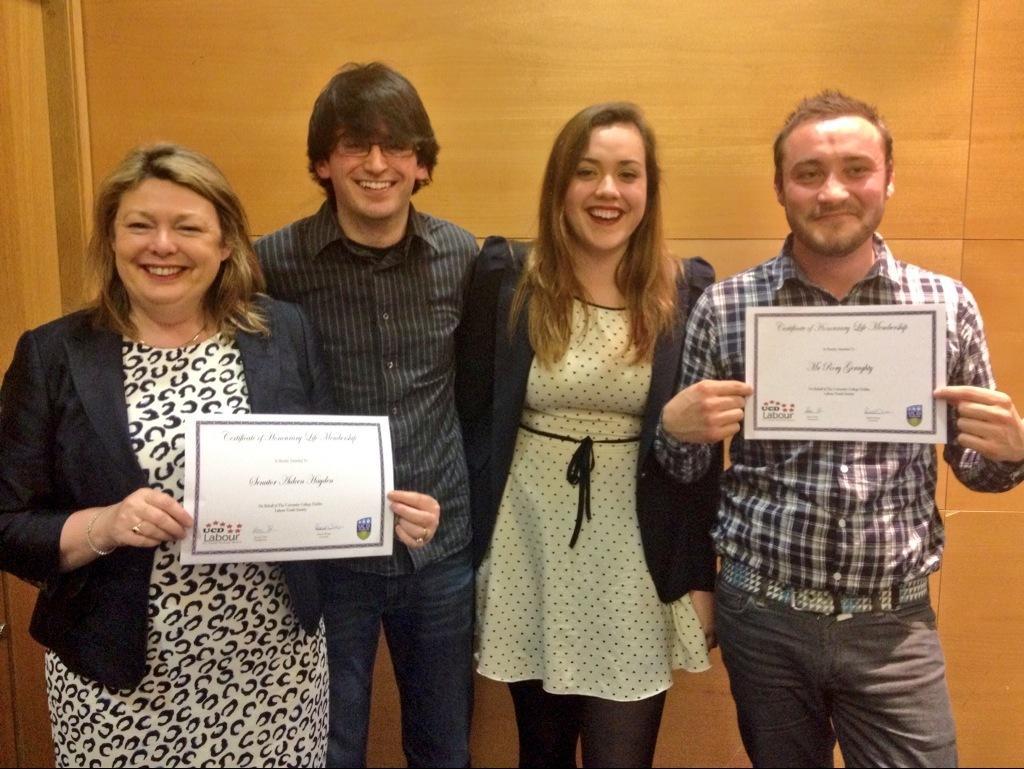In one or two sentences, can you explain what this image depicts? In this picture I can see few people standing and couple of them holding certificates in their hands. I can see a wooden wall in the background. 